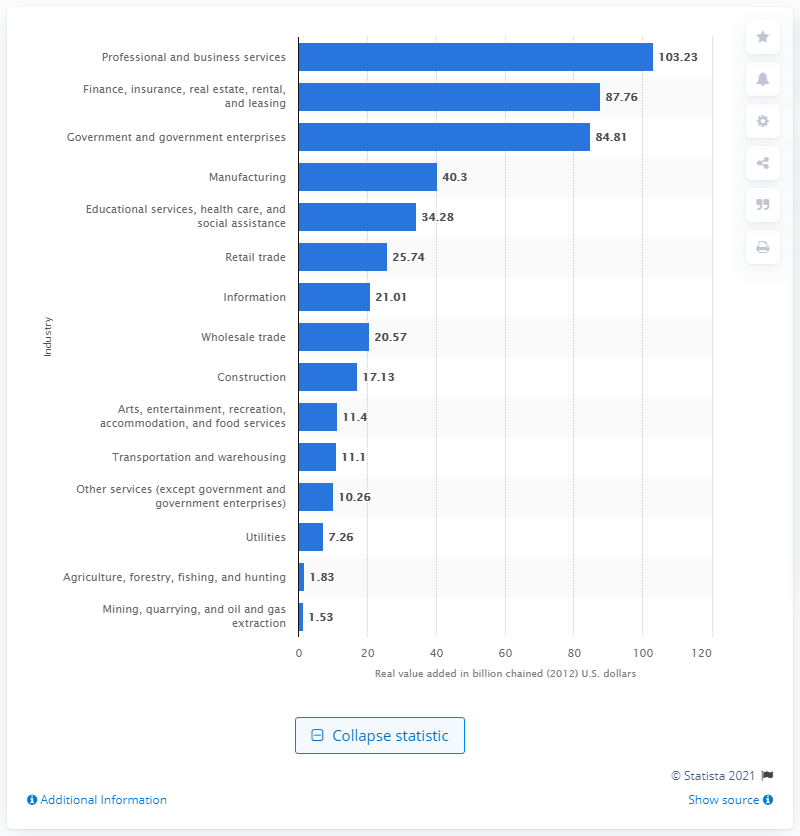Identify some key points in this picture. In 2012, the mining industry contributed approximately $1.53 billion to the gross domestic product (GDP) of Virginia. 